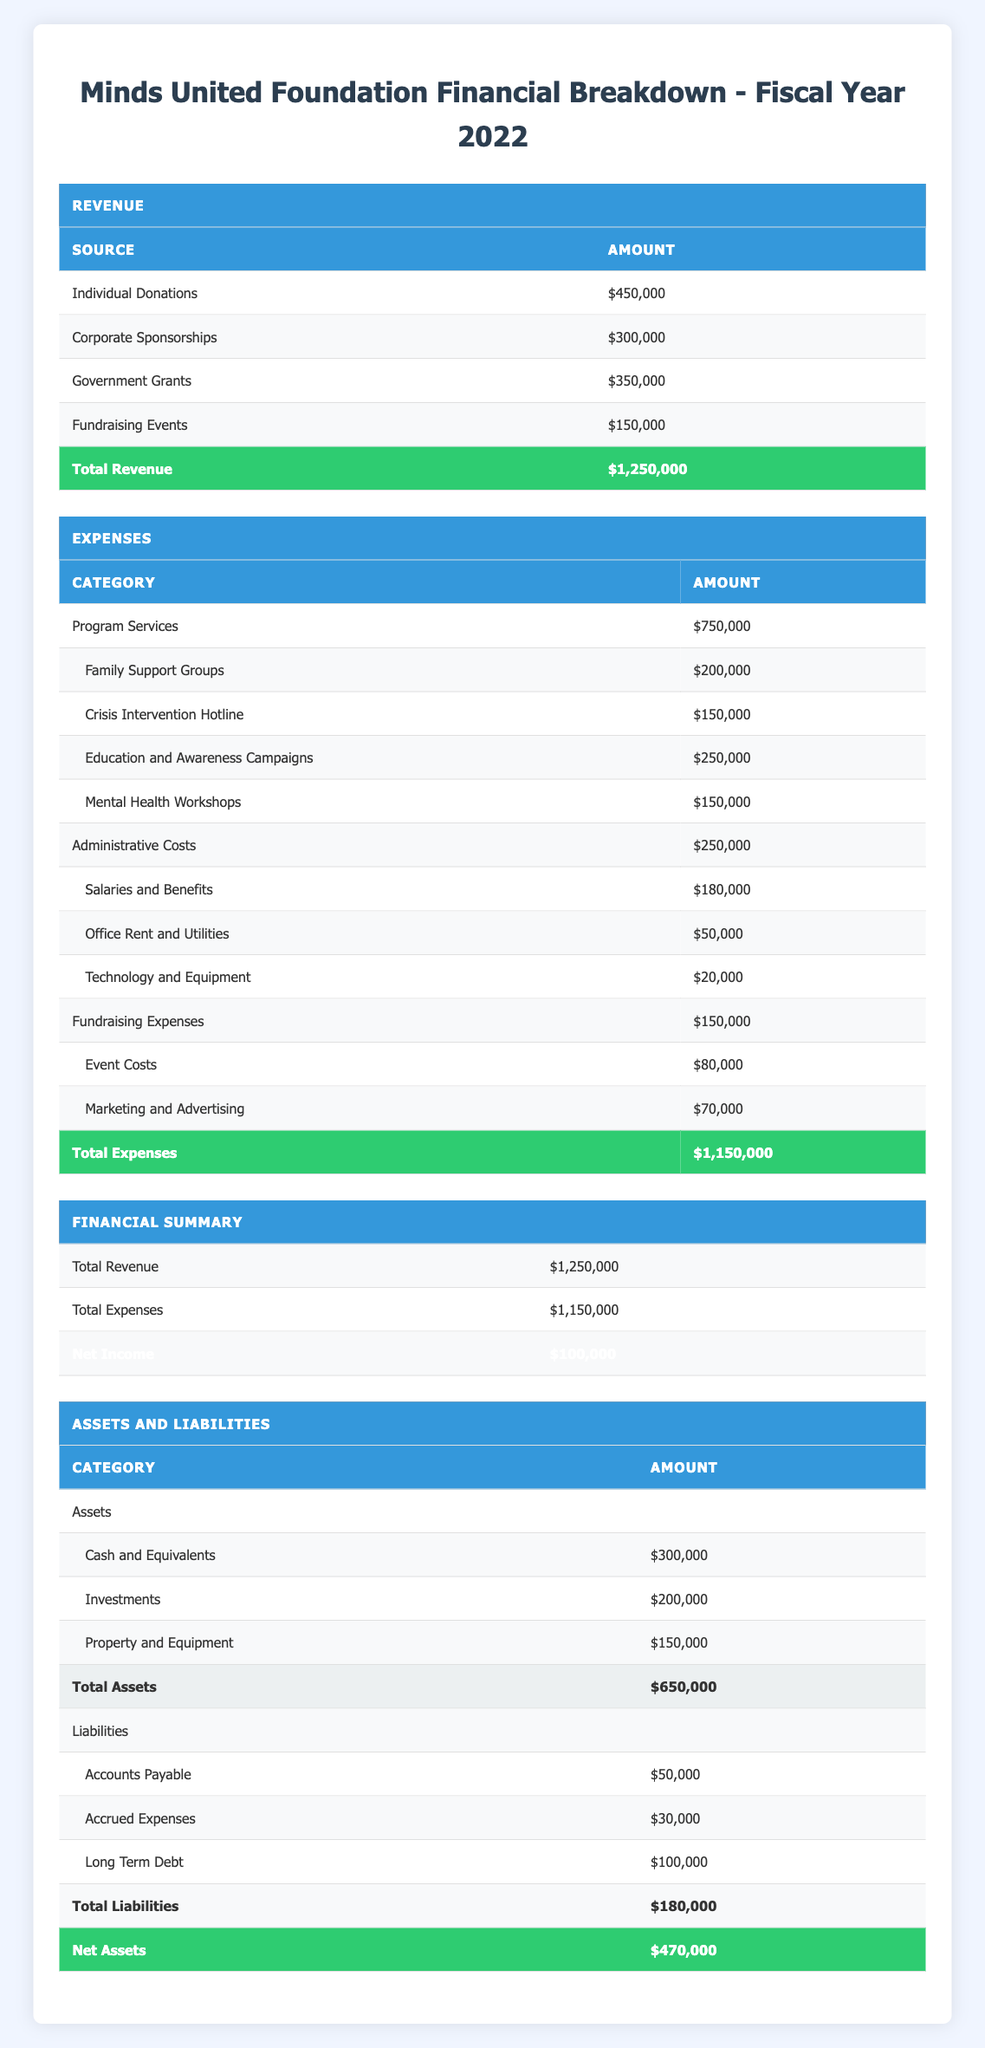What is the total revenue for Minds United Foundation in fiscal year 2022? The table states the total revenue at the bottom of the revenue section. It shows that the total revenue is $1,250,000.
Answer: $1,250,000 How much did the organization spend on Program Services? The table lists the total amount spent on Program Services. That amount is indicated as $750,000 directly in the expenses section.
Answer: $750,000 What is the amount allocated for Family Support Groups? Under the Program Services category in the expenses section, a line indicates that Family Support Groups received $200,000.
Answer: $200,000 Did the Minds United Foundation have a net income for the fiscal year 2022? The net income is presented at the end of the financial summary section, which states that the net income is $100,000, indicating that the organization did have a net income.
Answer: Yes What are the total expenses for Fundraising Expenses? In the expenses section, Fundraising Expenses is listed, showing a total of $150,000. This value can directly be found in the expenses table.
Answer: $150,000 What percentage of the total revenue is made up by Government Grants? To calculate the percentage, divide the amount of Government Grants ($350,000) by the total revenue ($1,250,000) and multiply by 100. This results in (350,000 / 1,250,000) * 100 = 28%.
Answer: 28% What is the total amount of assets the Minds United Foundation has? The assets section shows individual amounts for Cash and Equivalents ($300,000), Investments ($200,000), and Property and Equipment ($150,000). Summing these gives a total of $650,000.
Answer: $650,000 What is the difference between total assets and total liabilities? The total assets are $650,000, and the total liabilities are provided as $180,000 in the liabilities section. The difference is calculated as $650,000 - $180,000 = $470,000.
Answer: $470,000 What category incurs the highest expenses? In the expenses section, Program Services is the category with the highest amount listed at $750,000, more than Administrative Costs and Fundraising Expenses.
Answer: Program Services 